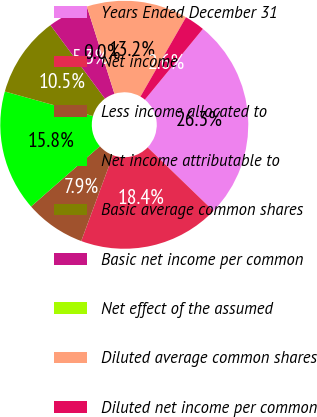Convert chart to OTSL. <chart><loc_0><loc_0><loc_500><loc_500><pie_chart><fcel>Years Ended December 31<fcel>Net income<fcel>Less income allocated to<fcel>Net income attributable to<fcel>Basic average common shares<fcel>Basic net income per common<fcel>Net effect of the assumed<fcel>Diluted average common shares<fcel>Diluted net income per common<nl><fcel>26.3%<fcel>18.41%<fcel>7.9%<fcel>15.78%<fcel>10.53%<fcel>5.27%<fcel>0.01%<fcel>13.16%<fcel>2.64%<nl></chart> 